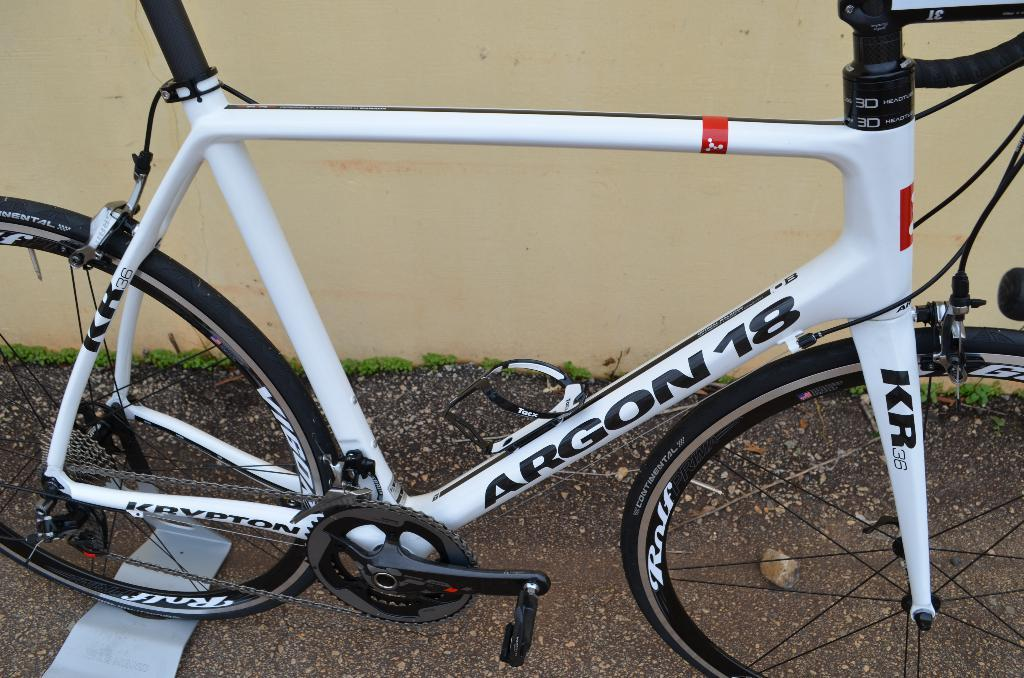What is the main object in the image? There is a bicycle in the image. How is the bicycle positioned in the image? The bicycle is parked on the ground. What else can be seen in the image besides the bicycle? There is a wall in the image. What type of hair can be seen on the bicycle in the image? There is no hair present on the bicycle in the image. 